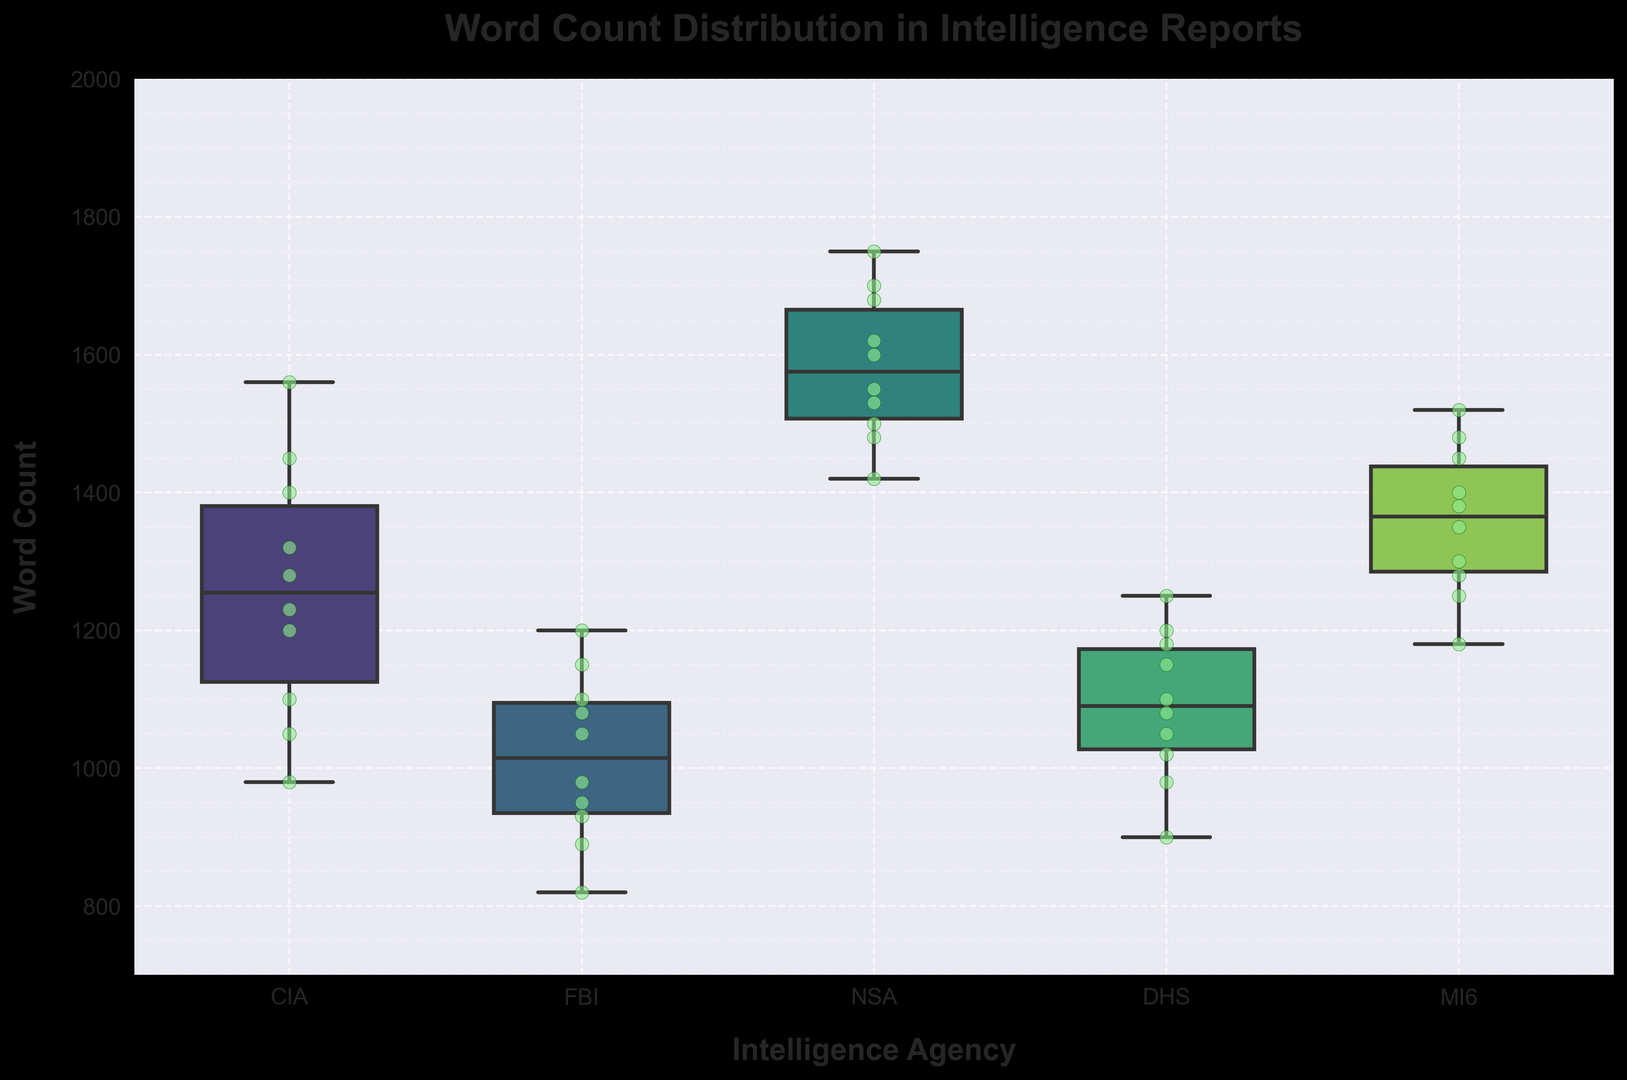What is the median Word Count for CIA reports? To find the median Word Count for CIA reports, look at the central line within the CIA box in the box plot. This line represents the median value.
Answer: 1230 What are the minimum and maximum Word Counts for NSA reports? The minimum and maximum values are indicated by the whiskers (the lines extending from the box). For the NSA, locate the bottom and top ends of these whiskers.
Answer: Minimum: 1420, Maximum: 1750 Which agency has the highest median Word Count? Compare the central line (median) within each agency's box. The agency with the highest median will have its central line positioned highest on the y-axis.
Answer: NSA How does the interquartile range (IQR) of the DHS compare to the MI6? The IQR is the range between the first quartile (bottom of the box) and the third quartile (top of the box). Visualize and compare the height of the boxes for both DHS and MI6.
Answer: MI6 has a larger IQR than DHS Which agency has the most variable report lengths based on outliers? Look for the agency with the most points outside the whiskers, which indicate outliers.
Answer: CIA Are there any outliers for FBI reports? Outliers are represented by individual points outside the whiskers in FBI's box plot.
Answer: No Which agency's reports have the lowest median Word Count? Identify the box with the lowest central line (median). Compare the agencies directly to find the lowest one.
Answer: FBI How does the range of Word Counts for DHS compare to CIA? The range is determined by the difference between the maximum and minimum values; compare the length of whiskers for both DHS and CIA.
Answer: The range for DHS is smaller than CIA Is there any overlap in the interquartile ranges (IQR) of MI6 and NSA reports? Check if the boxes for MI6 and NSA overlap on the y-axis, which represents the IQR.
Answer: No What is the position of CIA reports’ longest Word Count compared to NSA reports’ shortest Word Count? Compare the highest outlier or whisker for CIA reports with the lowest whisker of the NSA reports.
Answer: CIA's longest Word Count is lower than NSA's shortest Word Count 